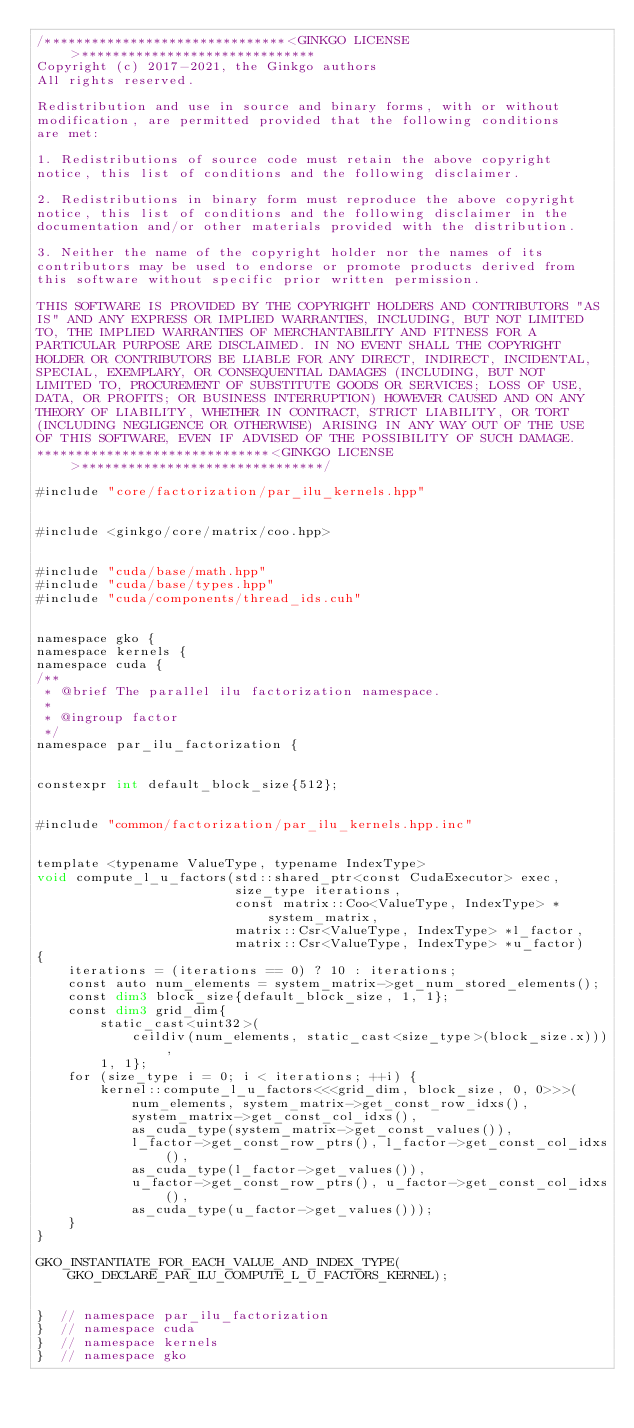<code> <loc_0><loc_0><loc_500><loc_500><_Cuda_>/*******************************<GINKGO LICENSE>******************************
Copyright (c) 2017-2021, the Ginkgo authors
All rights reserved.

Redistribution and use in source and binary forms, with or without
modification, are permitted provided that the following conditions
are met:

1. Redistributions of source code must retain the above copyright
notice, this list of conditions and the following disclaimer.

2. Redistributions in binary form must reproduce the above copyright
notice, this list of conditions and the following disclaimer in the
documentation and/or other materials provided with the distribution.

3. Neither the name of the copyright holder nor the names of its
contributors may be used to endorse or promote products derived from
this software without specific prior written permission.

THIS SOFTWARE IS PROVIDED BY THE COPYRIGHT HOLDERS AND CONTRIBUTORS "AS
IS" AND ANY EXPRESS OR IMPLIED WARRANTIES, INCLUDING, BUT NOT LIMITED
TO, THE IMPLIED WARRANTIES OF MERCHANTABILITY AND FITNESS FOR A
PARTICULAR PURPOSE ARE DISCLAIMED. IN NO EVENT SHALL THE COPYRIGHT
HOLDER OR CONTRIBUTORS BE LIABLE FOR ANY DIRECT, INDIRECT, INCIDENTAL,
SPECIAL, EXEMPLARY, OR CONSEQUENTIAL DAMAGES (INCLUDING, BUT NOT
LIMITED TO, PROCUREMENT OF SUBSTITUTE GOODS OR SERVICES; LOSS OF USE,
DATA, OR PROFITS; OR BUSINESS INTERRUPTION) HOWEVER CAUSED AND ON ANY
THEORY OF LIABILITY, WHETHER IN CONTRACT, STRICT LIABILITY, OR TORT
(INCLUDING NEGLIGENCE OR OTHERWISE) ARISING IN ANY WAY OUT OF THE USE
OF THIS SOFTWARE, EVEN IF ADVISED OF THE POSSIBILITY OF SUCH DAMAGE.
******************************<GINKGO LICENSE>*******************************/

#include "core/factorization/par_ilu_kernels.hpp"


#include <ginkgo/core/matrix/coo.hpp>


#include "cuda/base/math.hpp"
#include "cuda/base/types.hpp"
#include "cuda/components/thread_ids.cuh"


namespace gko {
namespace kernels {
namespace cuda {
/**
 * @brief The parallel ilu factorization namespace.
 *
 * @ingroup factor
 */
namespace par_ilu_factorization {


constexpr int default_block_size{512};


#include "common/factorization/par_ilu_kernels.hpp.inc"


template <typename ValueType, typename IndexType>
void compute_l_u_factors(std::shared_ptr<const CudaExecutor> exec,
                         size_type iterations,
                         const matrix::Coo<ValueType, IndexType> *system_matrix,
                         matrix::Csr<ValueType, IndexType> *l_factor,
                         matrix::Csr<ValueType, IndexType> *u_factor)
{
    iterations = (iterations == 0) ? 10 : iterations;
    const auto num_elements = system_matrix->get_num_stored_elements();
    const dim3 block_size{default_block_size, 1, 1};
    const dim3 grid_dim{
        static_cast<uint32>(
            ceildiv(num_elements, static_cast<size_type>(block_size.x))),
        1, 1};
    for (size_type i = 0; i < iterations; ++i) {
        kernel::compute_l_u_factors<<<grid_dim, block_size, 0, 0>>>(
            num_elements, system_matrix->get_const_row_idxs(),
            system_matrix->get_const_col_idxs(),
            as_cuda_type(system_matrix->get_const_values()),
            l_factor->get_const_row_ptrs(), l_factor->get_const_col_idxs(),
            as_cuda_type(l_factor->get_values()),
            u_factor->get_const_row_ptrs(), u_factor->get_const_col_idxs(),
            as_cuda_type(u_factor->get_values()));
    }
}

GKO_INSTANTIATE_FOR_EACH_VALUE_AND_INDEX_TYPE(
    GKO_DECLARE_PAR_ILU_COMPUTE_L_U_FACTORS_KERNEL);


}  // namespace par_ilu_factorization
}  // namespace cuda
}  // namespace kernels
}  // namespace gko
</code> 